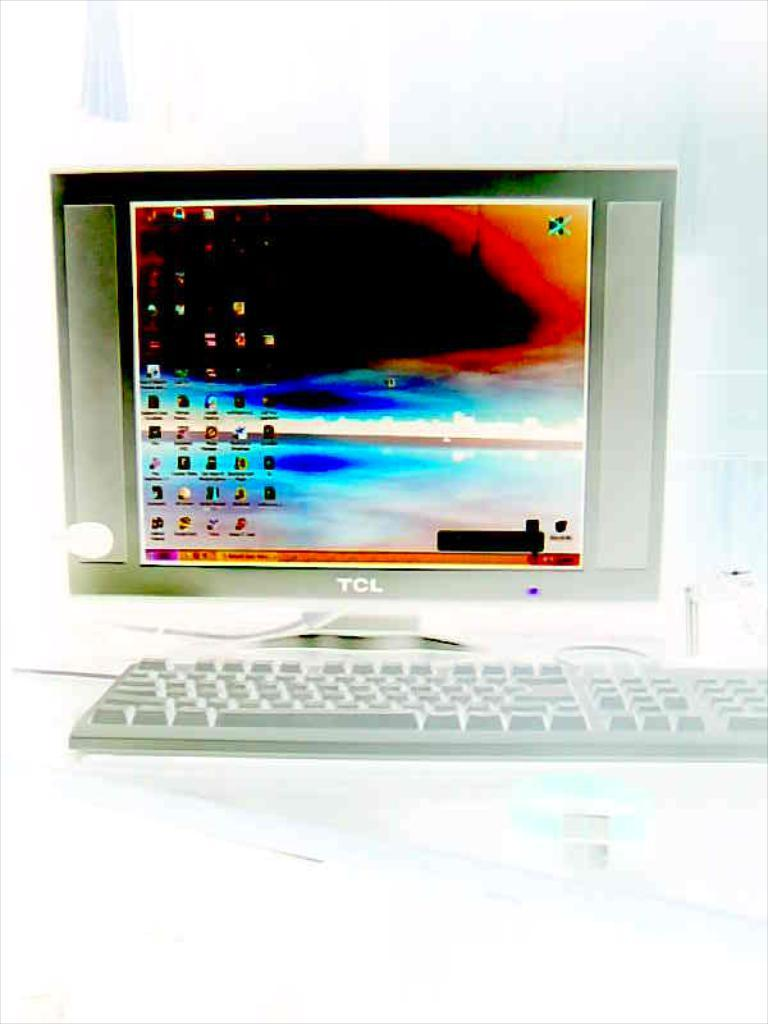<image>
Relay a brief, clear account of the picture shown. A TCL monitor has a black hole surrounding by other colors on the screen. 